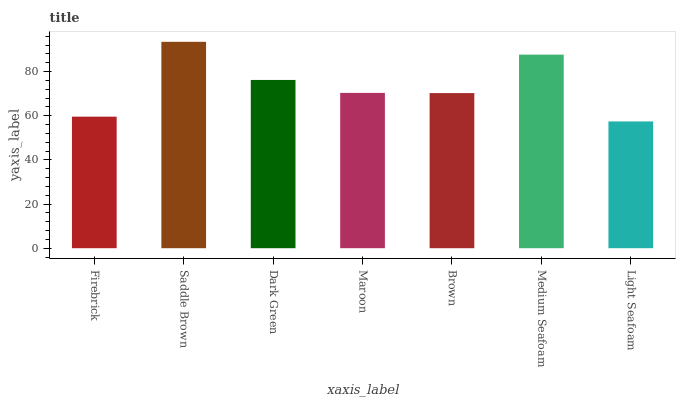Is Light Seafoam the minimum?
Answer yes or no. Yes. Is Saddle Brown the maximum?
Answer yes or no. Yes. Is Dark Green the minimum?
Answer yes or no. No. Is Dark Green the maximum?
Answer yes or no. No. Is Saddle Brown greater than Dark Green?
Answer yes or no. Yes. Is Dark Green less than Saddle Brown?
Answer yes or no. Yes. Is Dark Green greater than Saddle Brown?
Answer yes or no. No. Is Saddle Brown less than Dark Green?
Answer yes or no. No. Is Maroon the high median?
Answer yes or no. Yes. Is Maroon the low median?
Answer yes or no. Yes. Is Light Seafoam the high median?
Answer yes or no. No. Is Brown the low median?
Answer yes or no. No. 